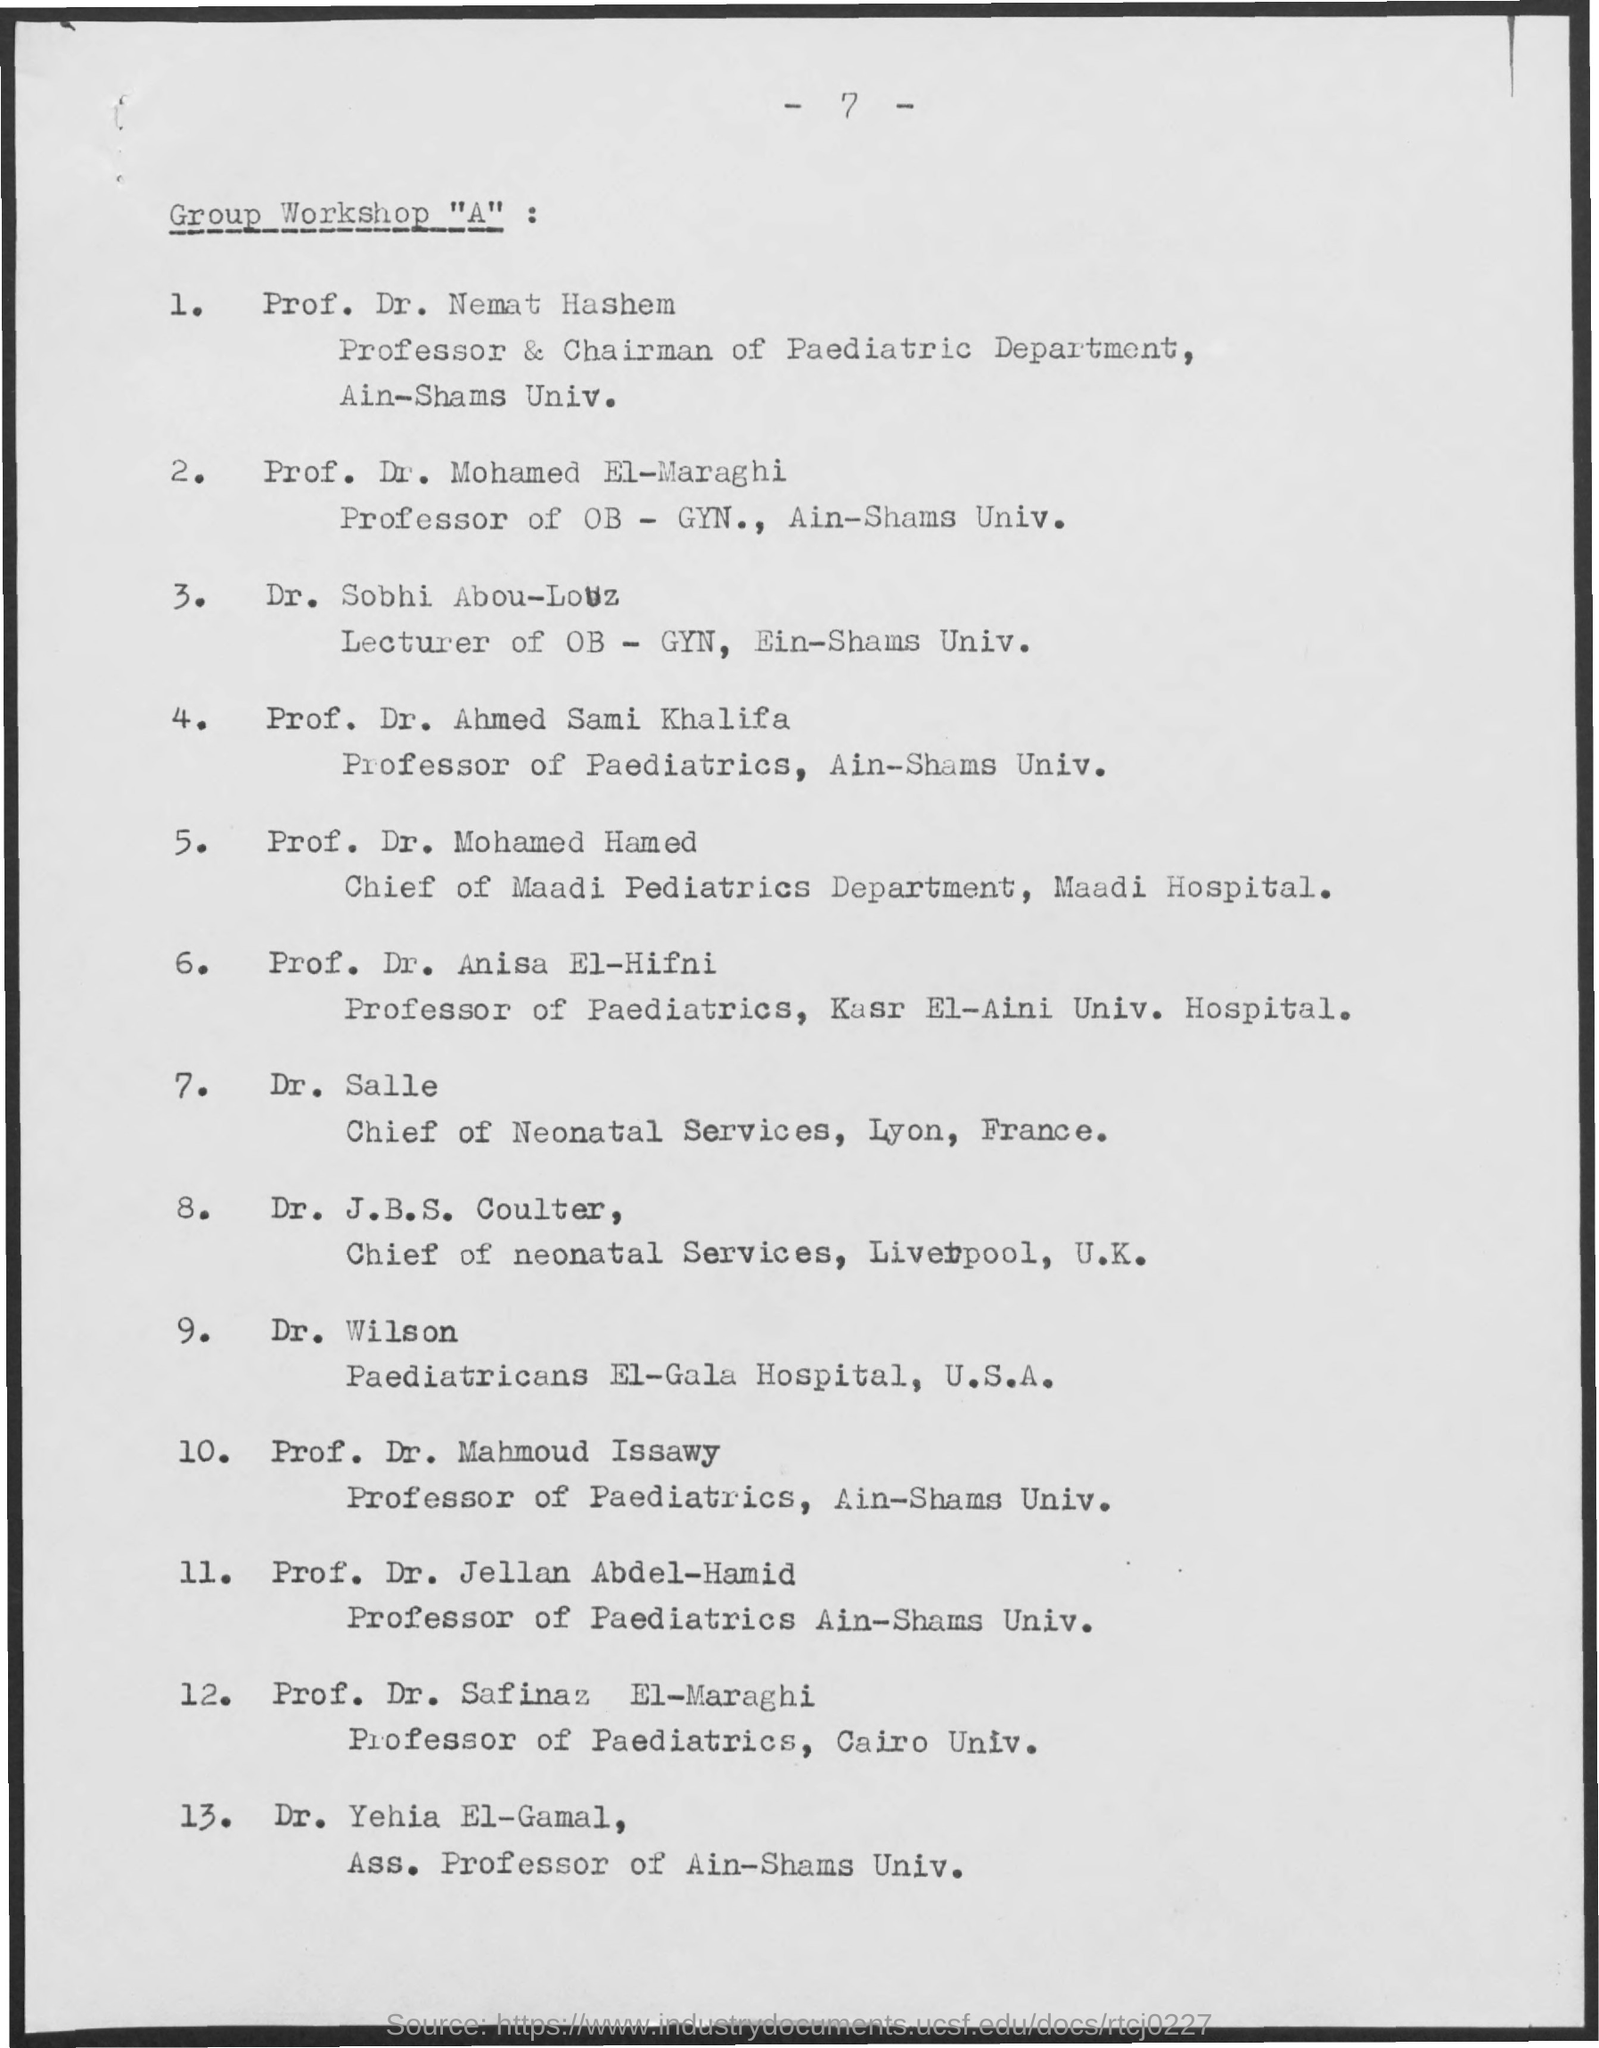Point out several critical features in this image. At EL-Gala Hospital, the paediatrician is Dr. Wilson. Professor Dr. Safinaz El-Maraghi is the professor of paediatrics at Cairo University. Dr. Mohamed EL-Maraghi is a professor of Obstetrics and Gynecology at Aim-shams University. The chief of neonatal Services at Lyon is Dr. Salle. Dr. Nemat Hashem is the chairman of the Paediatric Department at Ain-Shams University. 